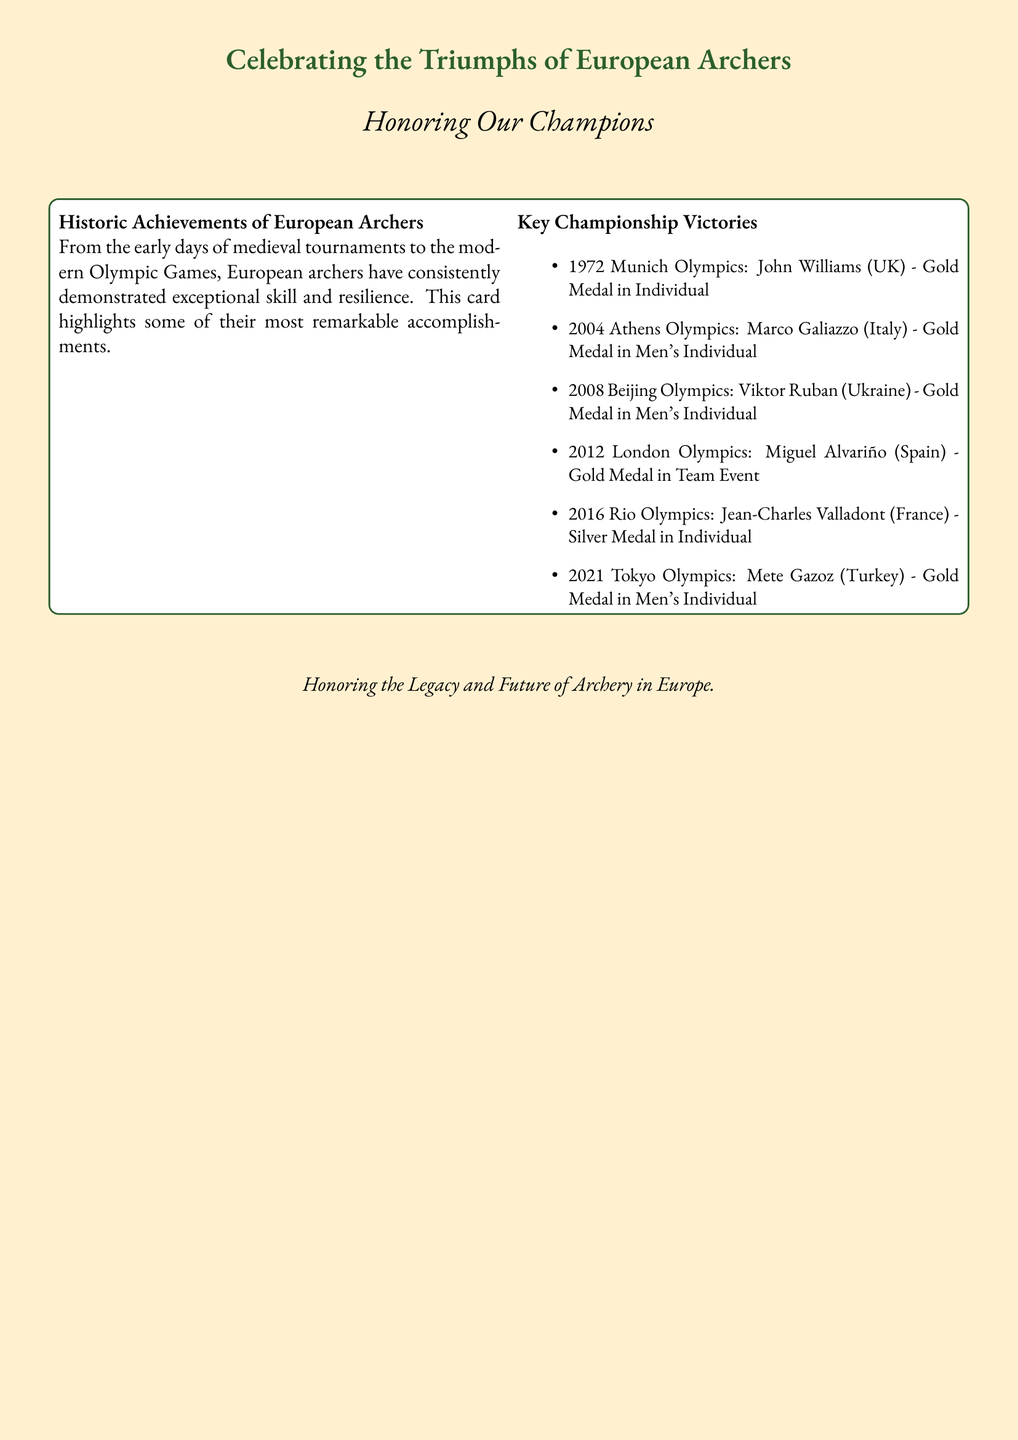What title is featured on the card? The title is prominently displayed at the top of the card, highlighting the theme of the document.
Answer: Celebrating the Triumphs of European Archers Which archer won the gold medal at the 2004 Athens Olympics? The document lists the achievements in chronological order, specifying medals earned by individual archers.
Answer: Marco Galiazzo How many Olympic gold medals are mentioned in the document? The document includes a specific list of achievements by European archers at the Olympics, summing the gold medals mentioned.
Answer: Four What is the color of the card's background? The document specifies the color scheme used for the card's design, indicating the background's hue.
Answer: Archery beige Which country's archer won the silver medal in the 2016 Rio Olympics? The document includes a list of key victories by country, pointing out the performance of individual archers.
Answer: France Who is honored as the gold medalist from Turkey in the Tokyo Olympics? The document highlights individual achievements from specific Olympic games, naming specific athletes with their accomplishments.
Answer: Mete Gazoz What is the main theme or purpose of the card? The document outlines the central message intended for the audience, focusing on achievements within the sport.
Answer: Honoring Our Champions Which archer from the UK won a gold medal in 1972? The document mentions specific winners from each Olympic event, identifying champions by name.
Answer: John Williams 